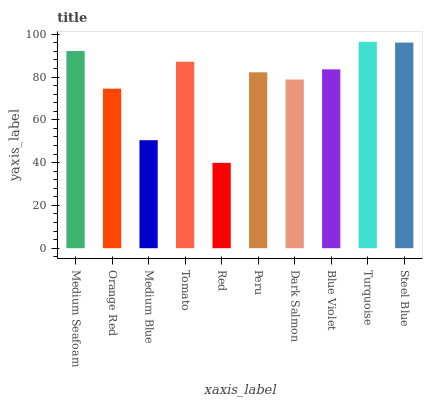Is Red the minimum?
Answer yes or no. Yes. Is Turquoise the maximum?
Answer yes or no. Yes. Is Orange Red the minimum?
Answer yes or no. No. Is Orange Red the maximum?
Answer yes or no. No. Is Medium Seafoam greater than Orange Red?
Answer yes or no. Yes. Is Orange Red less than Medium Seafoam?
Answer yes or no. Yes. Is Orange Red greater than Medium Seafoam?
Answer yes or no. No. Is Medium Seafoam less than Orange Red?
Answer yes or no. No. Is Blue Violet the high median?
Answer yes or no. Yes. Is Peru the low median?
Answer yes or no. Yes. Is Red the high median?
Answer yes or no. No. Is Orange Red the low median?
Answer yes or no. No. 